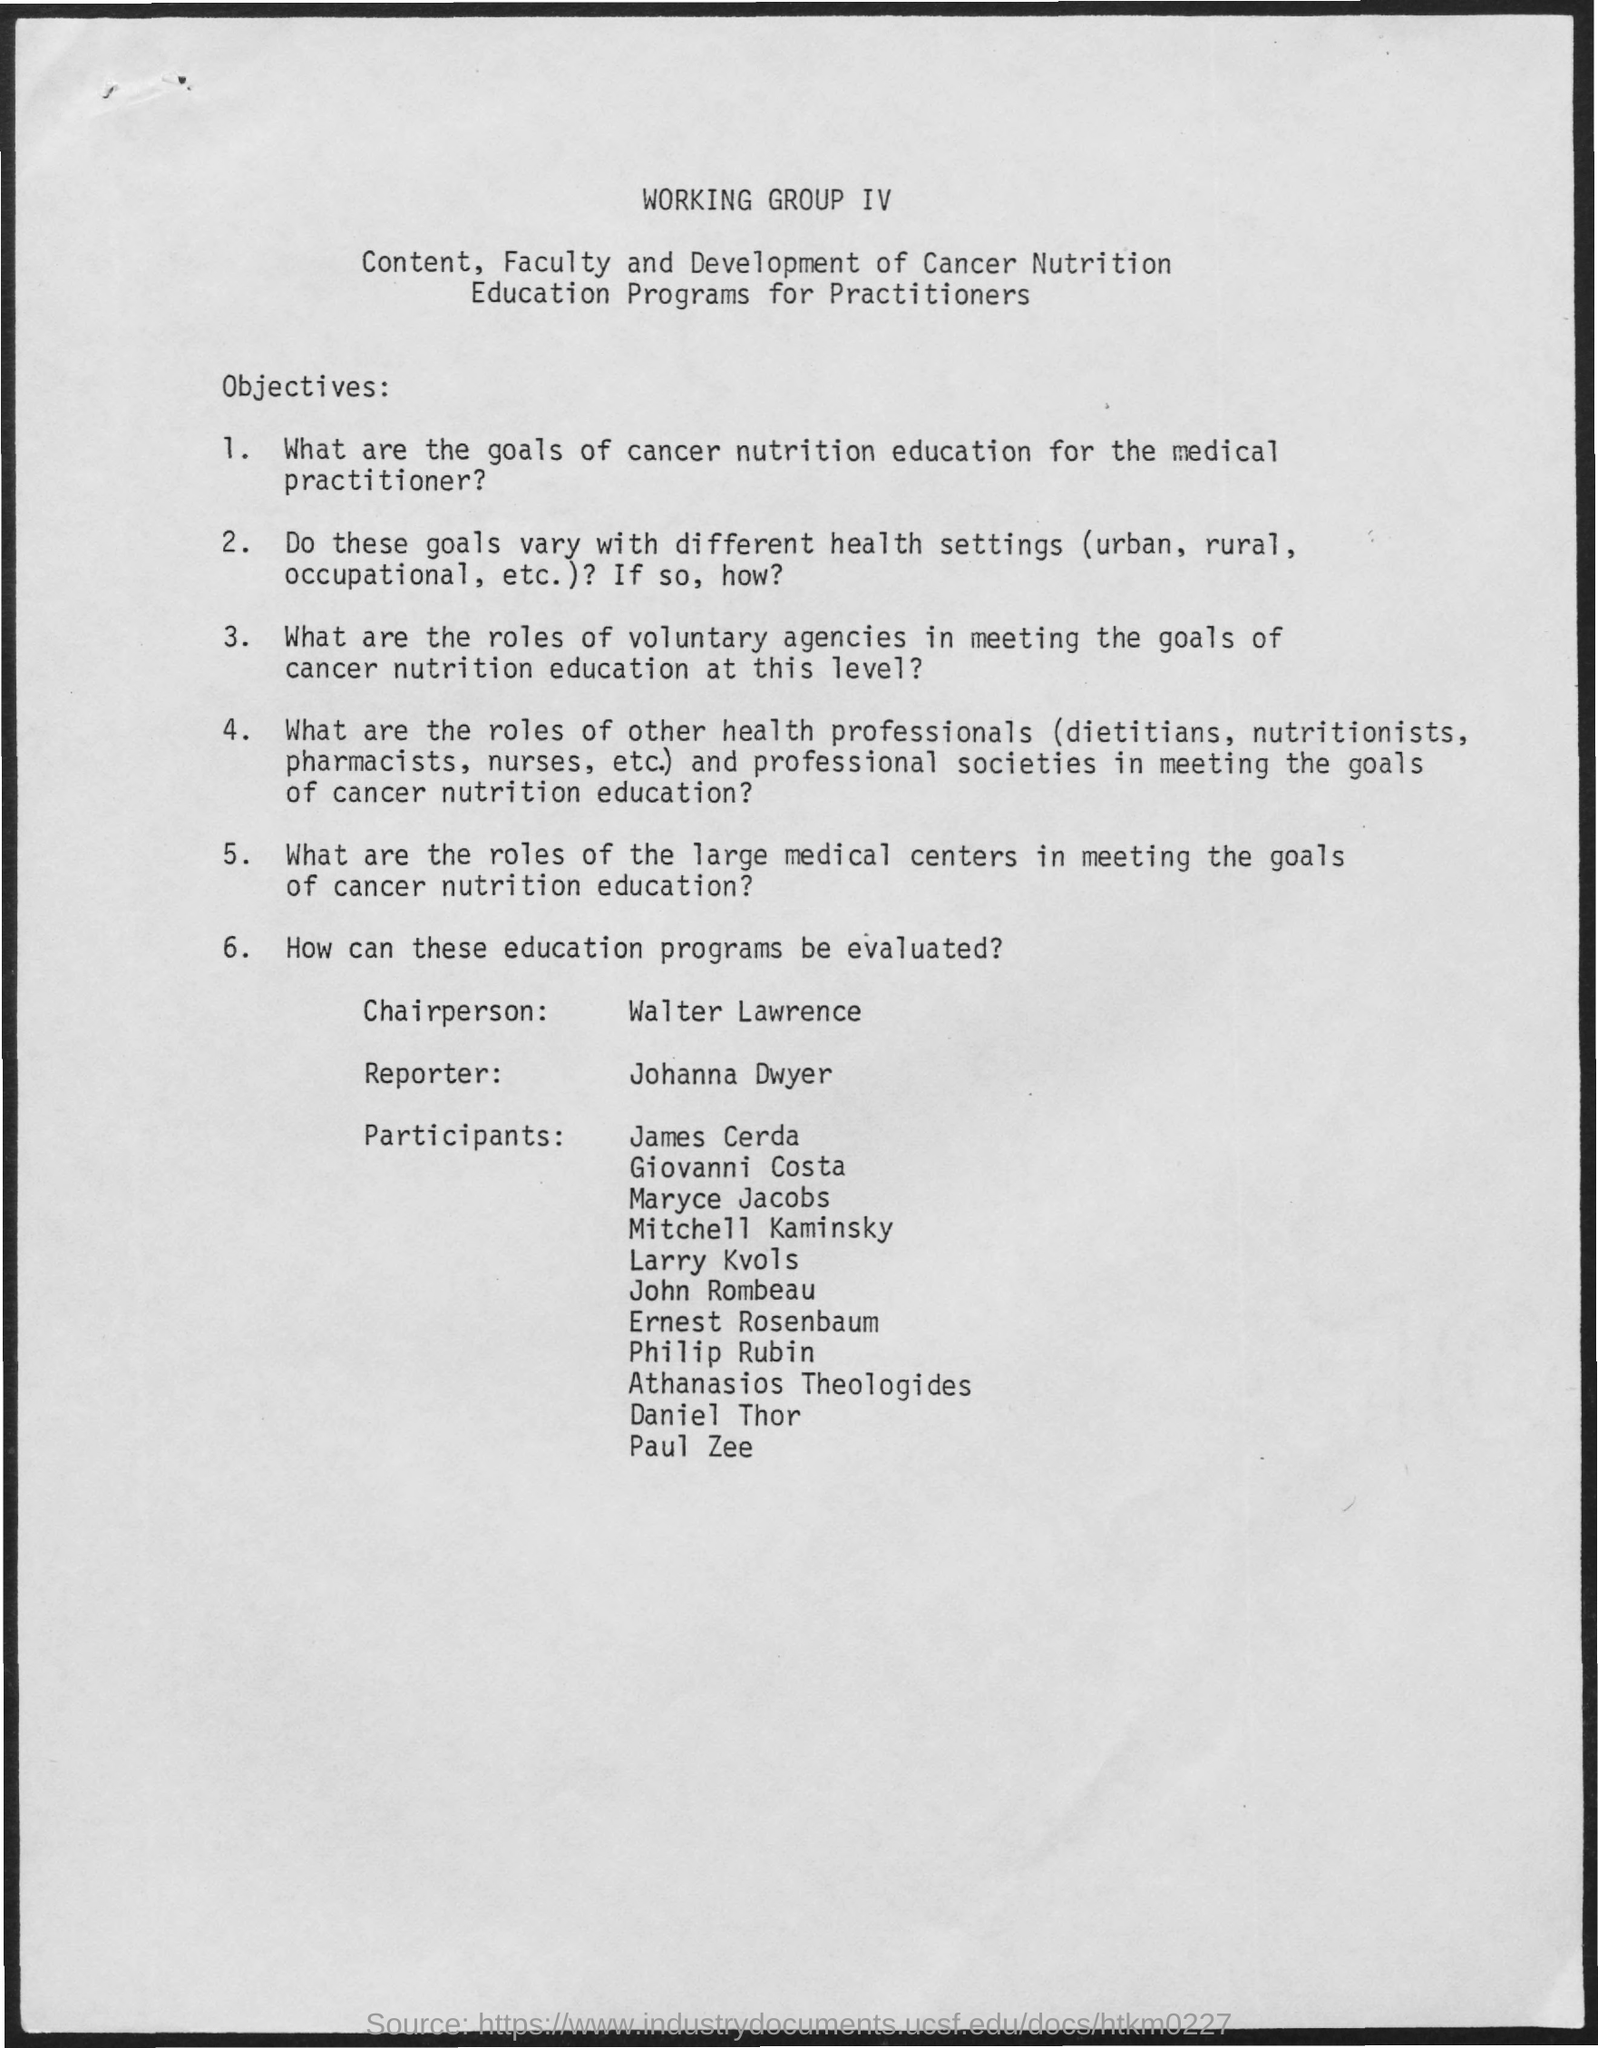Can you summarize the main objective of this working group? The main objective of the Working Group IV is to develop and enhance cancer nutrition education programs for practitioners. This includes setting goals for such programs, examining how these goals may vary across different health settings, exploring the roles of health professionals and voluntary agencies, and looking at the involvement of large medical centers. Additionally, there's a focus on how such education programs can be evaluated for effectiveness. 